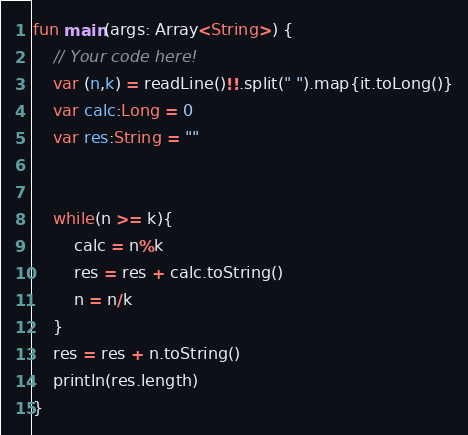Convert code to text. <code><loc_0><loc_0><loc_500><loc_500><_Kotlin_>fun main(args: Array<String>) {
    // Your code here!
    var (n,k) = readLine()!!.split(" ").map{it.toLong()}
    var calc:Long = 0
    var res:String = ""
    
    
    while(n >= k){
        calc = n%k
        res = res + calc.toString()
        n = n/k
    }
    res = res + n.toString()
    println(res.length)
}
</code> 